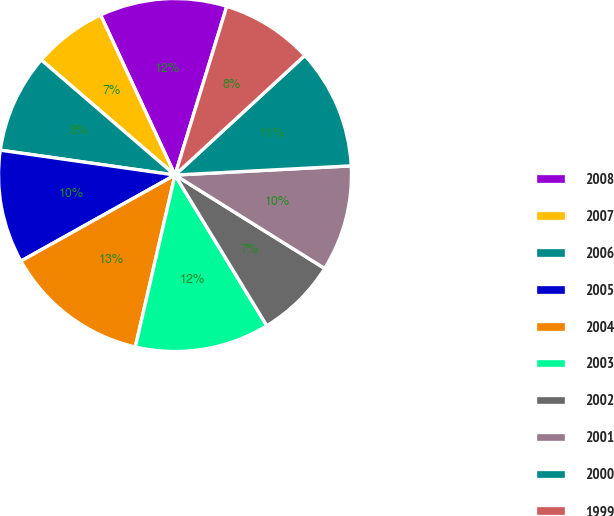<chart> <loc_0><loc_0><loc_500><loc_500><pie_chart><fcel>2008<fcel>2007<fcel>2006<fcel>2005<fcel>2004<fcel>2003<fcel>2002<fcel>2001<fcel>2000<fcel>1999<nl><fcel>11.67%<fcel>6.76%<fcel>9.06%<fcel>10.36%<fcel>13.28%<fcel>12.32%<fcel>7.41%<fcel>9.71%<fcel>11.02%<fcel>8.41%<nl></chart> 